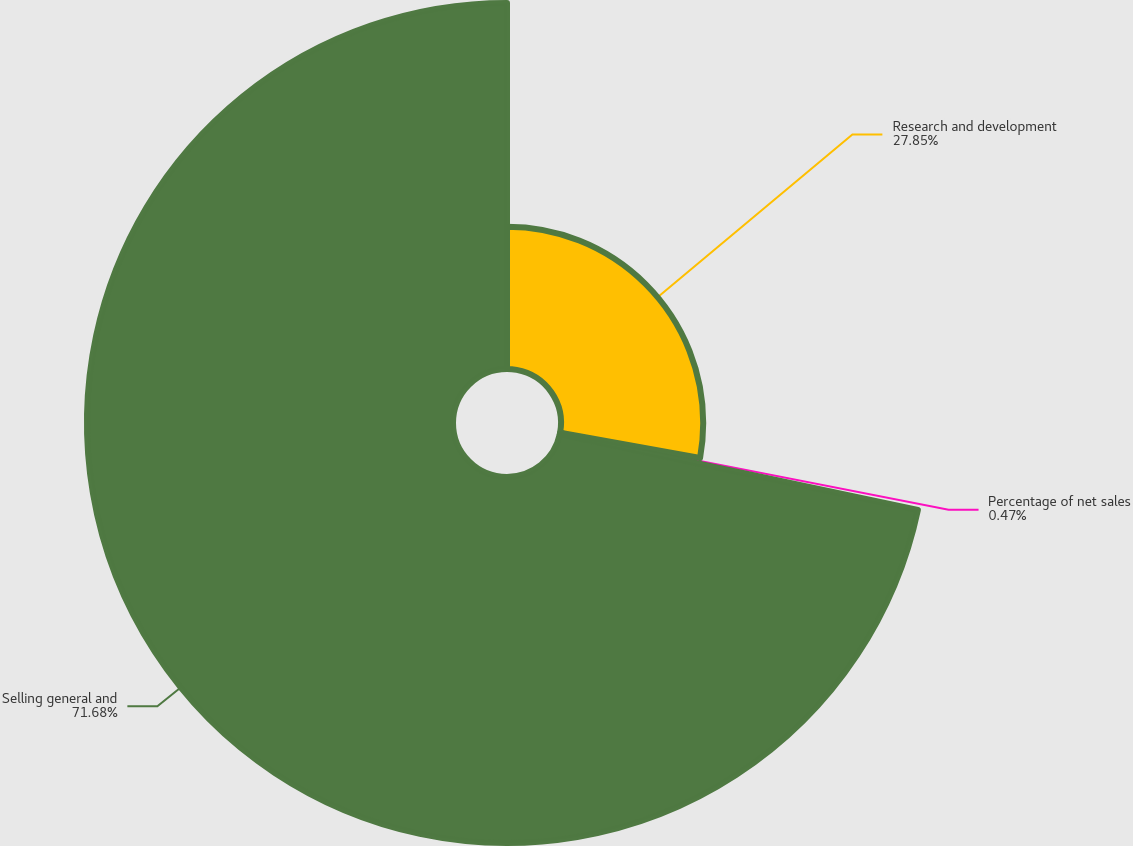Convert chart. <chart><loc_0><loc_0><loc_500><loc_500><pie_chart><fcel>Research and development<fcel>Percentage of net sales<fcel>Selling general and<nl><fcel>27.85%<fcel>0.47%<fcel>71.67%<nl></chart> 